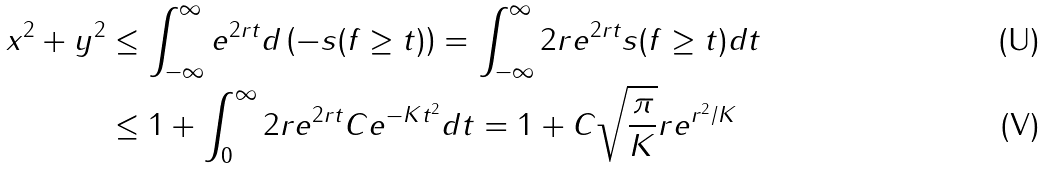<formula> <loc_0><loc_0><loc_500><loc_500>x ^ { 2 } + y ^ { 2 } & \leq \int _ { - \infty } ^ { \infty } e ^ { 2 r t } d \left ( - s ( f \geq t ) \right ) = \int _ { - \infty } ^ { \infty } 2 r e ^ { 2 r t } s ( f \geq t ) d t \\ & \leq 1 + \int _ { 0 } ^ { \infty } 2 r e ^ { 2 r t } C e ^ { - K t ^ { 2 } } d t = 1 + C \sqrt { \frac { \pi } { K } } r e ^ { r ^ { 2 } / K }</formula> 